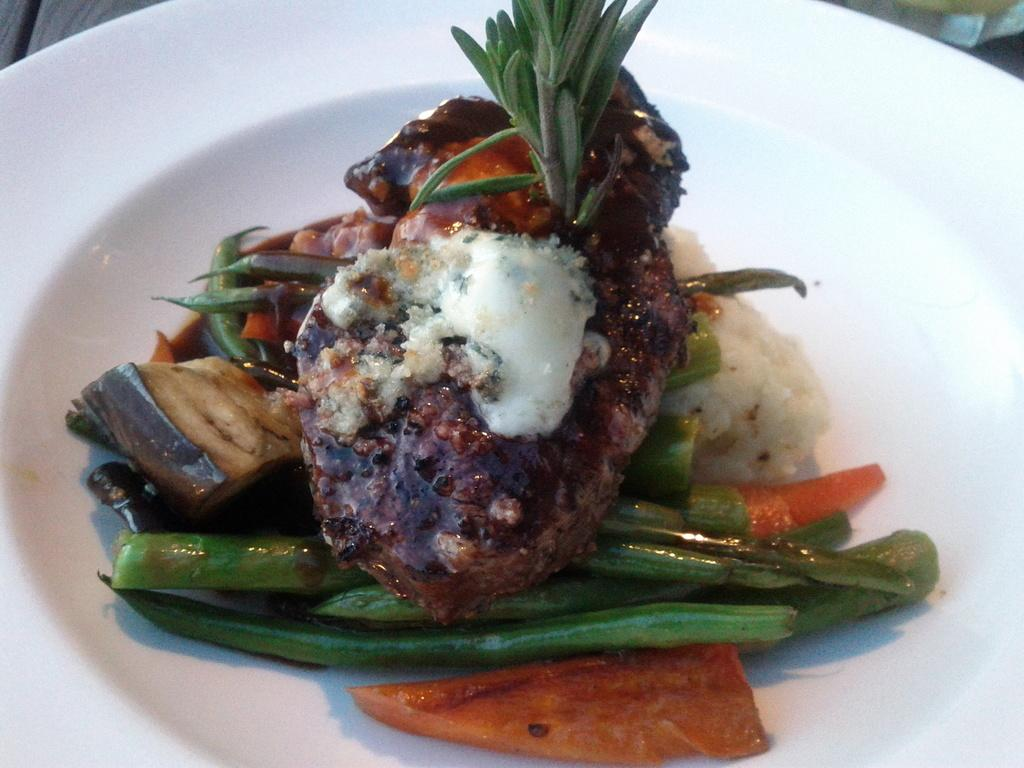What is on the plate in the image? There are food items on a plate in the image. What color is the plate? The plate is white. What is the plate resting on? The plate is placed on a wooden platform. How many rabbits can be seen on the canvas in the image? There is no canvas or rabbits present in the image. What type of noise can be heard coming from the food items on the plate? The food items on the plate are not making any noise in the image. 